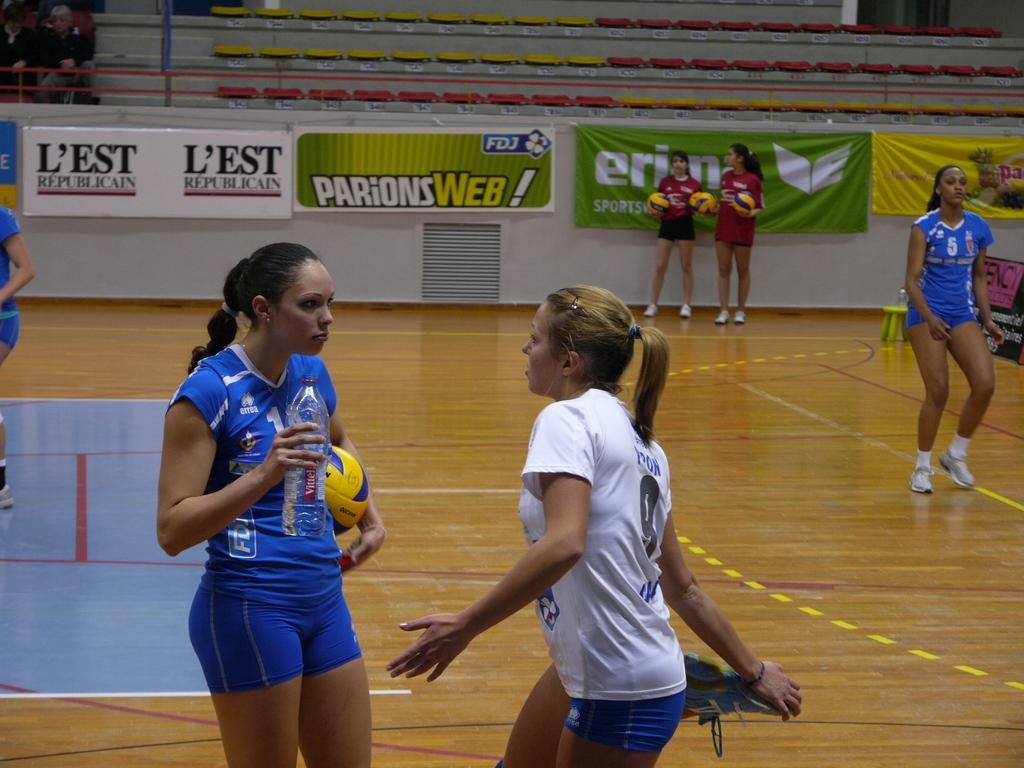What is happening in the image? There are people standing in the image. Can you describe the woman on the left side? The woman on the left side is holding a ball. What can be seen in the background of the image? There are hoardings and banners in the background of the image. What type of tree can be seen in the image? There is no tree present in the image. Can you describe the clouds in the image? There are no clouds visible in the image. 